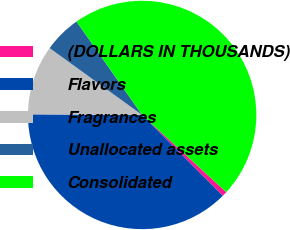<chart> <loc_0><loc_0><loc_500><loc_500><pie_chart><fcel>(DOLLARS IN THOUSANDS)<fcel>Flavors<fcel>Fragrances<fcel>Unallocated assets<fcel>Consolidated<nl><fcel>0.7%<fcel>37.57%<fcel>9.87%<fcel>5.29%<fcel>46.57%<nl></chart> 